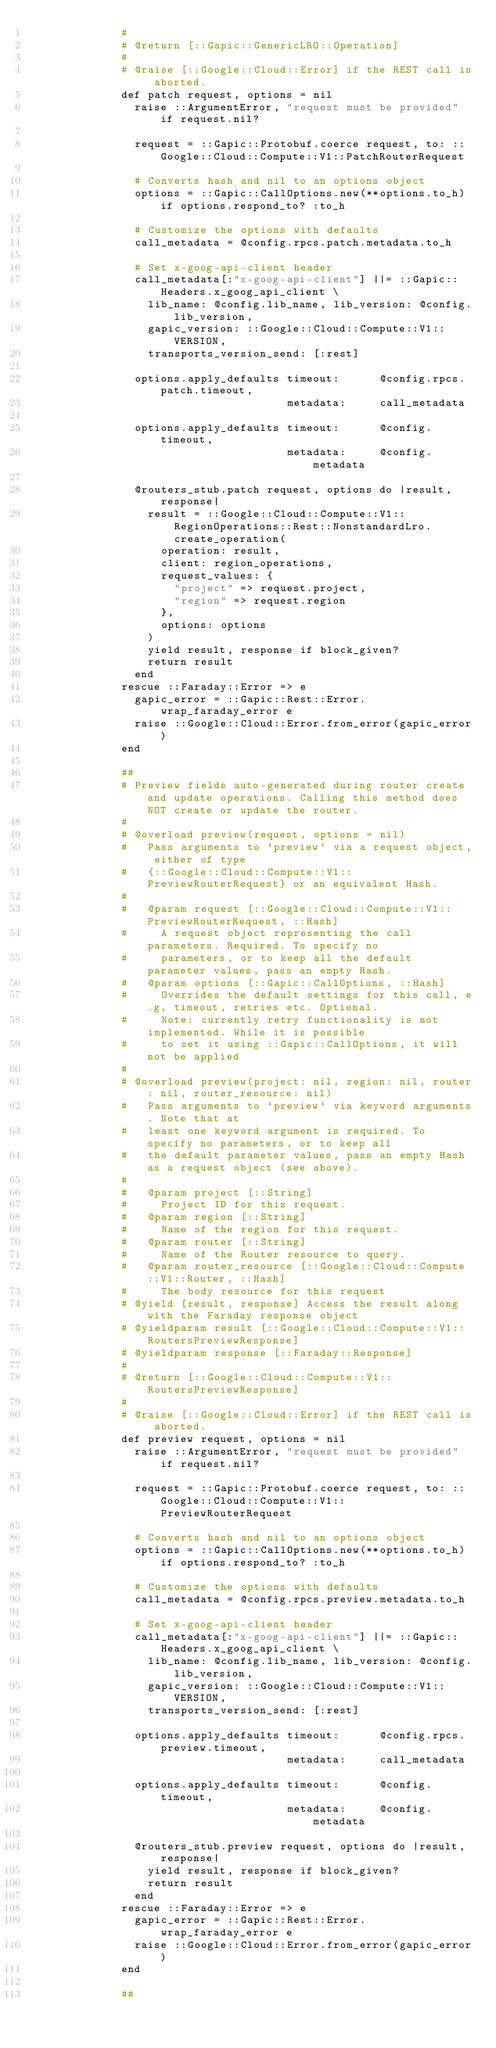Convert code to text. <code><loc_0><loc_0><loc_500><loc_500><_Ruby_>              #
              # @return [::Gapic::GenericLRO::Operation]
              #
              # @raise [::Google::Cloud::Error] if the REST call is aborted.
              def patch request, options = nil
                raise ::ArgumentError, "request must be provided" if request.nil?

                request = ::Gapic::Protobuf.coerce request, to: ::Google::Cloud::Compute::V1::PatchRouterRequest

                # Converts hash and nil to an options object
                options = ::Gapic::CallOptions.new(**options.to_h) if options.respond_to? :to_h

                # Customize the options with defaults
                call_metadata = @config.rpcs.patch.metadata.to_h

                # Set x-goog-api-client header
                call_metadata[:"x-goog-api-client"] ||= ::Gapic::Headers.x_goog_api_client \
                  lib_name: @config.lib_name, lib_version: @config.lib_version,
                  gapic_version: ::Google::Cloud::Compute::V1::VERSION,
                  transports_version_send: [:rest]

                options.apply_defaults timeout:      @config.rpcs.patch.timeout,
                                       metadata:     call_metadata

                options.apply_defaults timeout:      @config.timeout,
                                       metadata:     @config.metadata

                @routers_stub.patch request, options do |result, response|
                  result = ::Google::Cloud::Compute::V1::RegionOperations::Rest::NonstandardLro.create_operation(
                    operation: result,
                    client: region_operations,
                    request_values: {
                      "project" => request.project,
                      "region" => request.region
                    },
                    options: options
                  )
                  yield result, response if block_given?
                  return result
                end
              rescue ::Faraday::Error => e
                gapic_error = ::Gapic::Rest::Error.wrap_faraday_error e
                raise ::Google::Cloud::Error.from_error(gapic_error)
              end

              ##
              # Preview fields auto-generated during router create and update operations. Calling this method does NOT create or update the router.
              #
              # @overload preview(request, options = nil)
              #   Pass arguments to `preview` via a request object, either of type
              #   {::Google::Cloud::Compute::V1::PreviewRouterRequest} or an equivalent Hash.
              #
              #   @param request [::Google::Cloud::Compute::V1::PreviewRouterRequest, ::Hash]
              #     A request object representing the call parameters. Required. To specify no
              #     parameters, or to keep all the default parameter values, pass an empty Hash.
              #   @param options [::Gapic::CallOptions, ::Hash]
              #     Overrides the default settings for this call, e.g, timeout, retries etc. Optional.
              #     Note: currently retry functionality is not implemented. While it is possible
              #     to set it using ::Gapic::CallOptions, it will not be applied
              #
              # @overload preview(project: nil, region: nil, router: nil, router_resource: nil)
              #   Pass arguments to `preview` via keyword arguments. Note that at
              #   least one keyword argument is required. To specify no parameters, or to keep all
              #   the default parameter values, pass an empty Hash as a request object (see above).
              #
              #   @param project [::String]
              #     Project ID for this request.
              #   @param region [::String]
              #     Name of the region for this request.
              #   @param router [::String]
              #     Name of the Router resource to query.
              #   @param router_resource [::Google::Cloud::Compute::V1::Router, ::Hash]
              #     The body resource for this request
              # @yield [result, response] Access the result along with the Faraday response object
              # @yieldparam result [::Google::Cloud::Compute::V1::RoutersPreviewResponse]
              # @yieldparam response [::Faraday::Response]
              #
              # @return [::Google::Cloud::Compute::V1::RoutersPreviewResponse]
              #
              # @raise [::Google::Cloud::Error] if the REST call is aborted.
              def preview request, options = nil
                raise ::ArgumentError, "request must be provided" if request.nil?

                request = ::Gapic::Protobuf.coerce request, to: ::Google::Cloud::Compute::V1::PreviewRouterRequest

                # Converts hash and nil to an options object
                options = ::Gapic::CallOptions.new(**options.to_h) if options.respond_to? :to_h

                # Customize the options with defaults
                call_metadata = @config.rpcs.preview.metadata.to_h

                # Set x-goog-api-client header
                call_metadata[:"x-goog-api-client"] ||= ::Gapic::Headers.x_goog_api_client \
                  lib_name: @config.lib_name, lib_version: @config.lib_version,
                  gapic_version: ::Google::Cloud::Compute::V1::VERSION,
                  transports_version_send: [:rest]

                options.apply_defaults timeout:      @config.rpcs.preview.timeout,
                                       metadata:     call_metadata

                options.apply_defaults timeout:      @config.timeout,
                                       metadata:     @config.metadata

                @routers_stub.preview request, options do |result, response|
                  yield result, response if block_given?
                  return result
                end
              rescue ::Faraday::Error => e
                gapic_error = ::Gapic::Rest::Error.wrap_faraday_error e
                raise ::Google::Cloud::Error.from_error(gapic_error)
              end

              ##</code> 